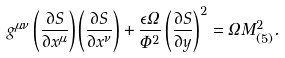<formula> <loc_0><loc_0><loc_500><loc_500>g ^ { \mu \nu } \left ( \frac { \partial S } { \partial x ^ { \mu } } \right ) \left ( \frac { \partial S } { \partial x ^ { \nu } } \right ) + \frac { \epsilon \Omega } { \Phi ^ { 2 } } \left ( \frac { \partial S } { \partial y } \right ) ^ { 2 } = \Omega M ^ { 2 } _ { ( 5 ) } .</formula> 